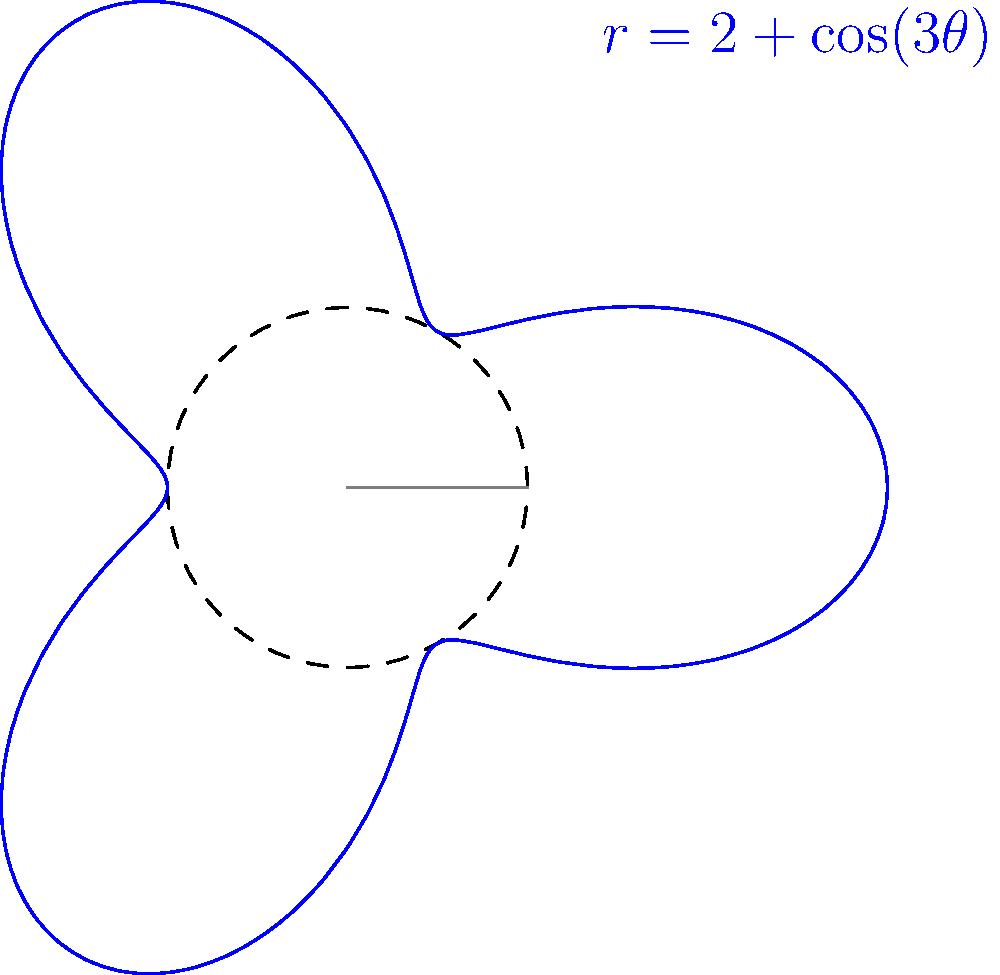In the polar coordinate system shown above, which represents a transformation for FPGA resource allocation, what is the maximum radial distance from the origin to the blue curve, and at which angle(s) does this occur? To solve this problem, we need to follow these steps:

1. Identify the equation of the curve: $r = 2 + \cos(3\theta)$

2. Find the maximum value of $r$:
   - The maximum value of $\cos(3\theta)$ is 1
   - Therefore, the maximum value of $r$ is when $\cos(3\theta) = 1$
   - $r_{max} = 2 + 1 = 3$

3. Find the angle(s) where this maximum occurs:
   - $\cos(3\theta) = 1$ when $3\theta = 0, 2\pi, 4\pi, ...$
   - Solving for $\theta$: $\theta = 0, \frac{2\pi}{3}, \frac{4\pi}{3}$

4. Convert to degrees (optional):
   - $0°, 120°, 240°$

The maximum radial distance is 3 units, occurring at angles $0, \frac{2\pi}{3},$ and $\frac{4\pi}{3}$ radians (or $0°, 120°,$ and $240°$).
Answer: 3 units; at $0, \frac{2\pi}{3}, \frac{4\pi}{3}$ radians 